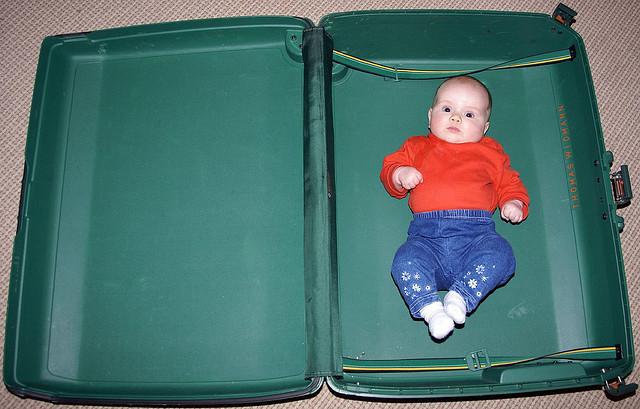What is the floor covered with?
Short answer required. Carpet. What is the kid lying on?
Write a very short answer. Suitcase. Is the baby safe?
Quick response, please. No. 